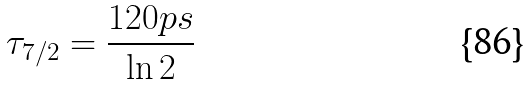Convert formula to latex. <formula><loc_0><loc_0><loc_500><loc_500>\tau _ { 7 / 2 } = { \frac { 1 2 0 { p s } } { \ln { 2 } } }</formula> 